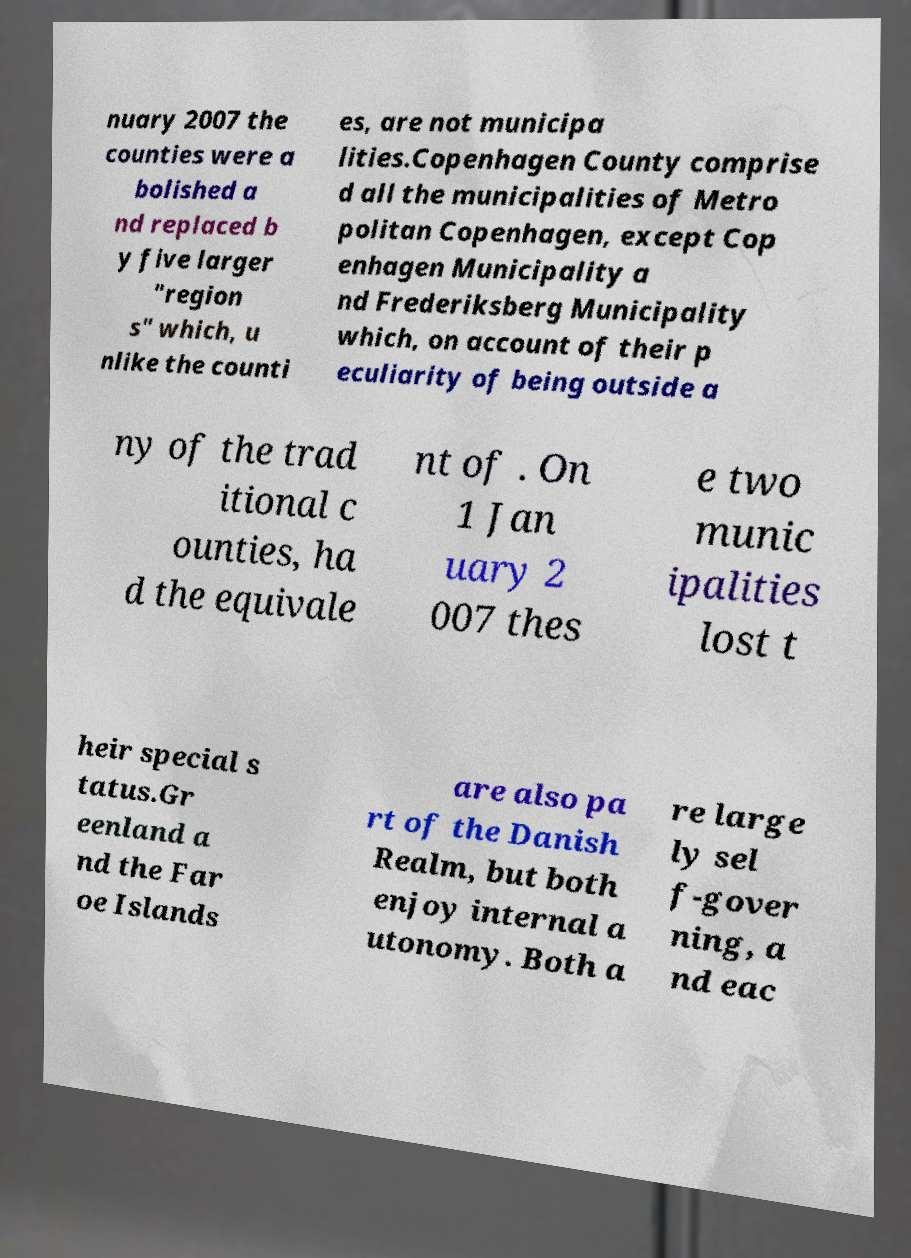I need the written content from this picture converted into text. Can you do that? nuary 2007 the counties were a bolished a nd replaced b y five larger "region s" which, u nlike the counti es, are not municipa lities.Copenhagen County comprise d all the municipalities of Metro politan Copenhagen, except Cop enhagen Municipality a nd Frederiksberg Municipality which, on account of their p eculiarity of being outside a ny of the trad itional c ounties, ha d the equivale nt of . On 1 Jan uary 2 007 thes e two munic ipalities lost t heir special s tatus.Gr eenland a nd the Far oe Islands are also pa rt of the Danish Realm, but both enjoy internal a utonomy. Both a re large ly sel f-gover ning, a nd eac 